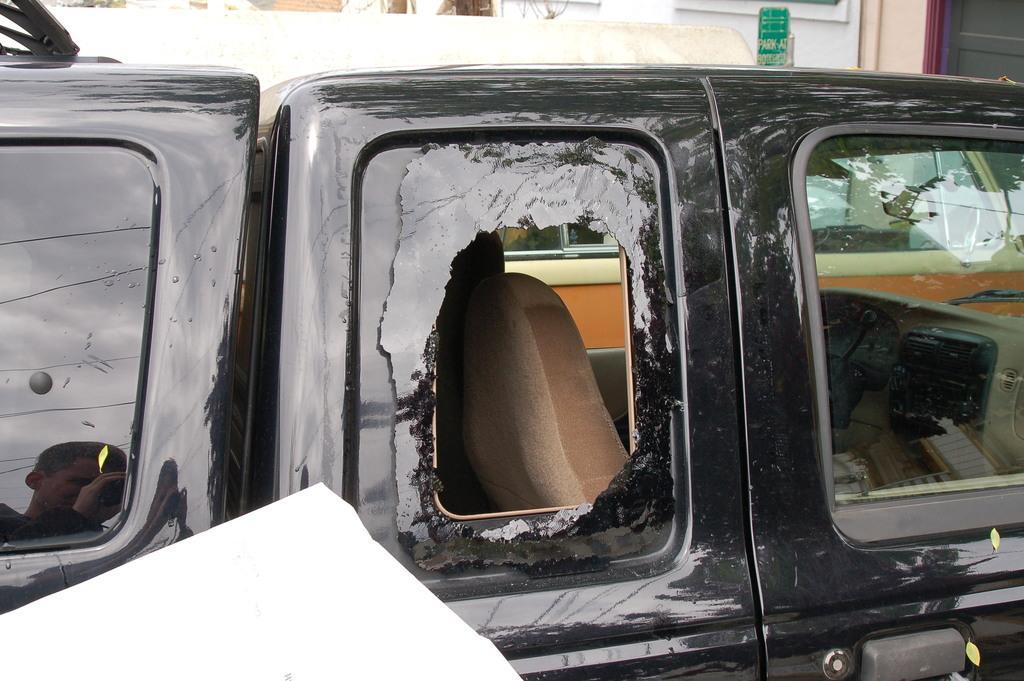Please provide a concise description of this image. There is a black color car having glass windows. Beside this car, there is a white color object. In the background, there is a building. 